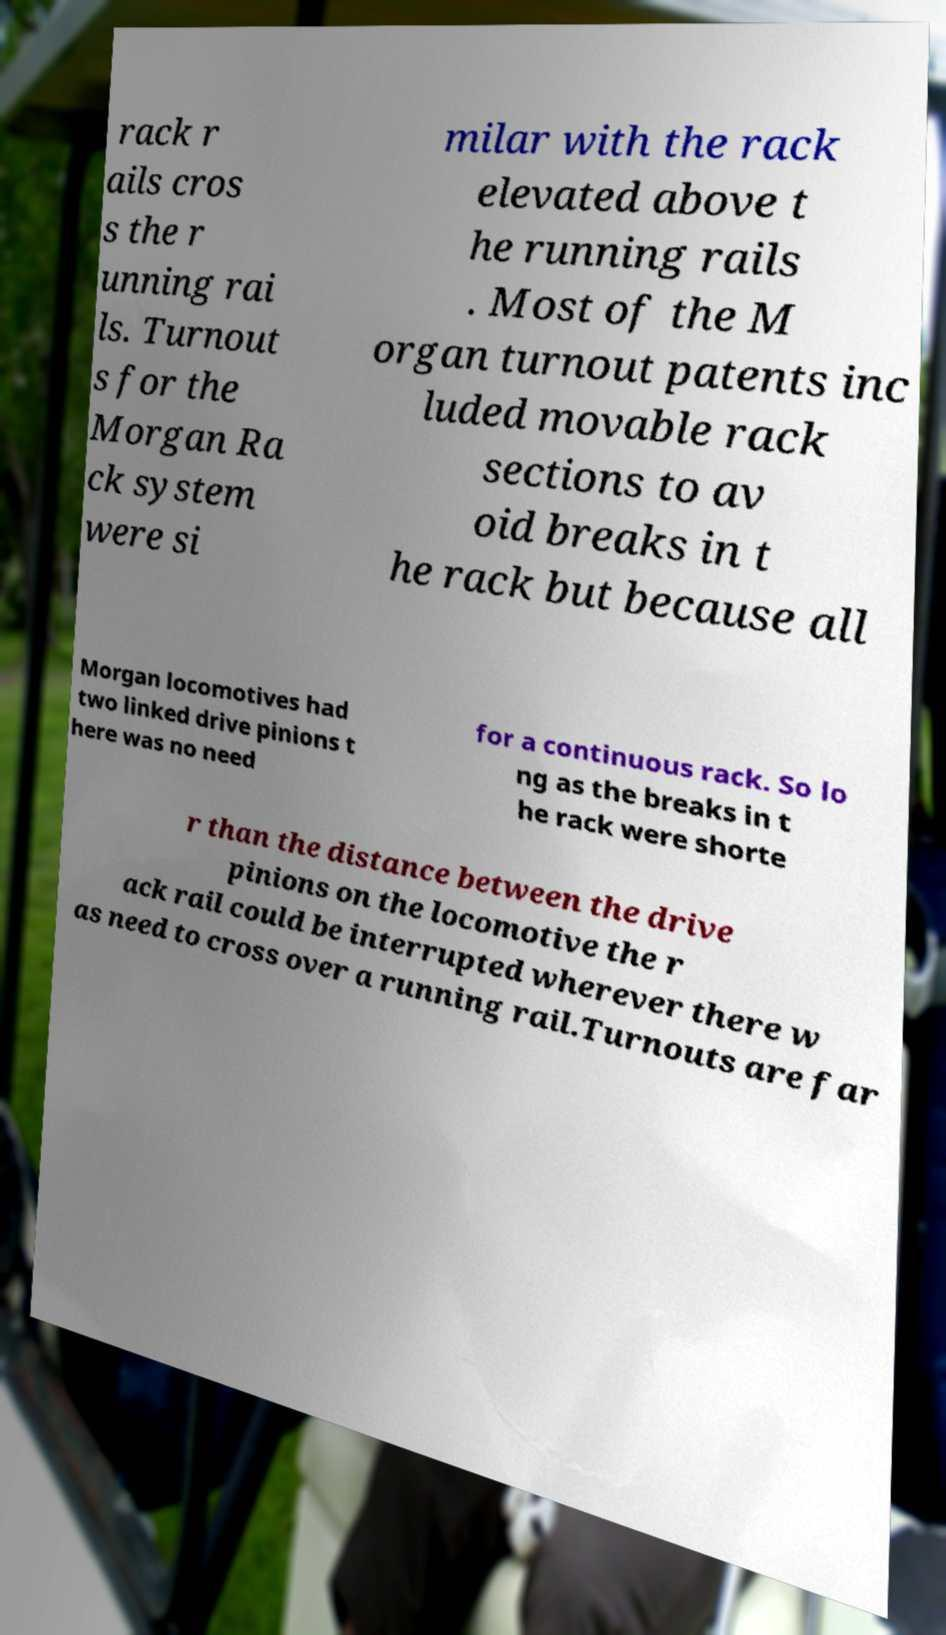I need the written content from this picture converted into text. Can you do that? rack r ails cros s the r unning rai ls. Turnout s for the Morgan Ra ck system were si milar with the rack elevated above t he running rails . Most of the M organ turnout patents inc luded movable rack sections to av oid breaks in t he rack but because all Morgan locomotives had two linked drive pinions t here was no need for a continuous rack. So lo ng as the breaks in t he rack were shorte r than the distance between the drive pinions on the locomotive the r ack rail could be interrupted wherever there w as need to cross over a running rail.Turnouts are far 